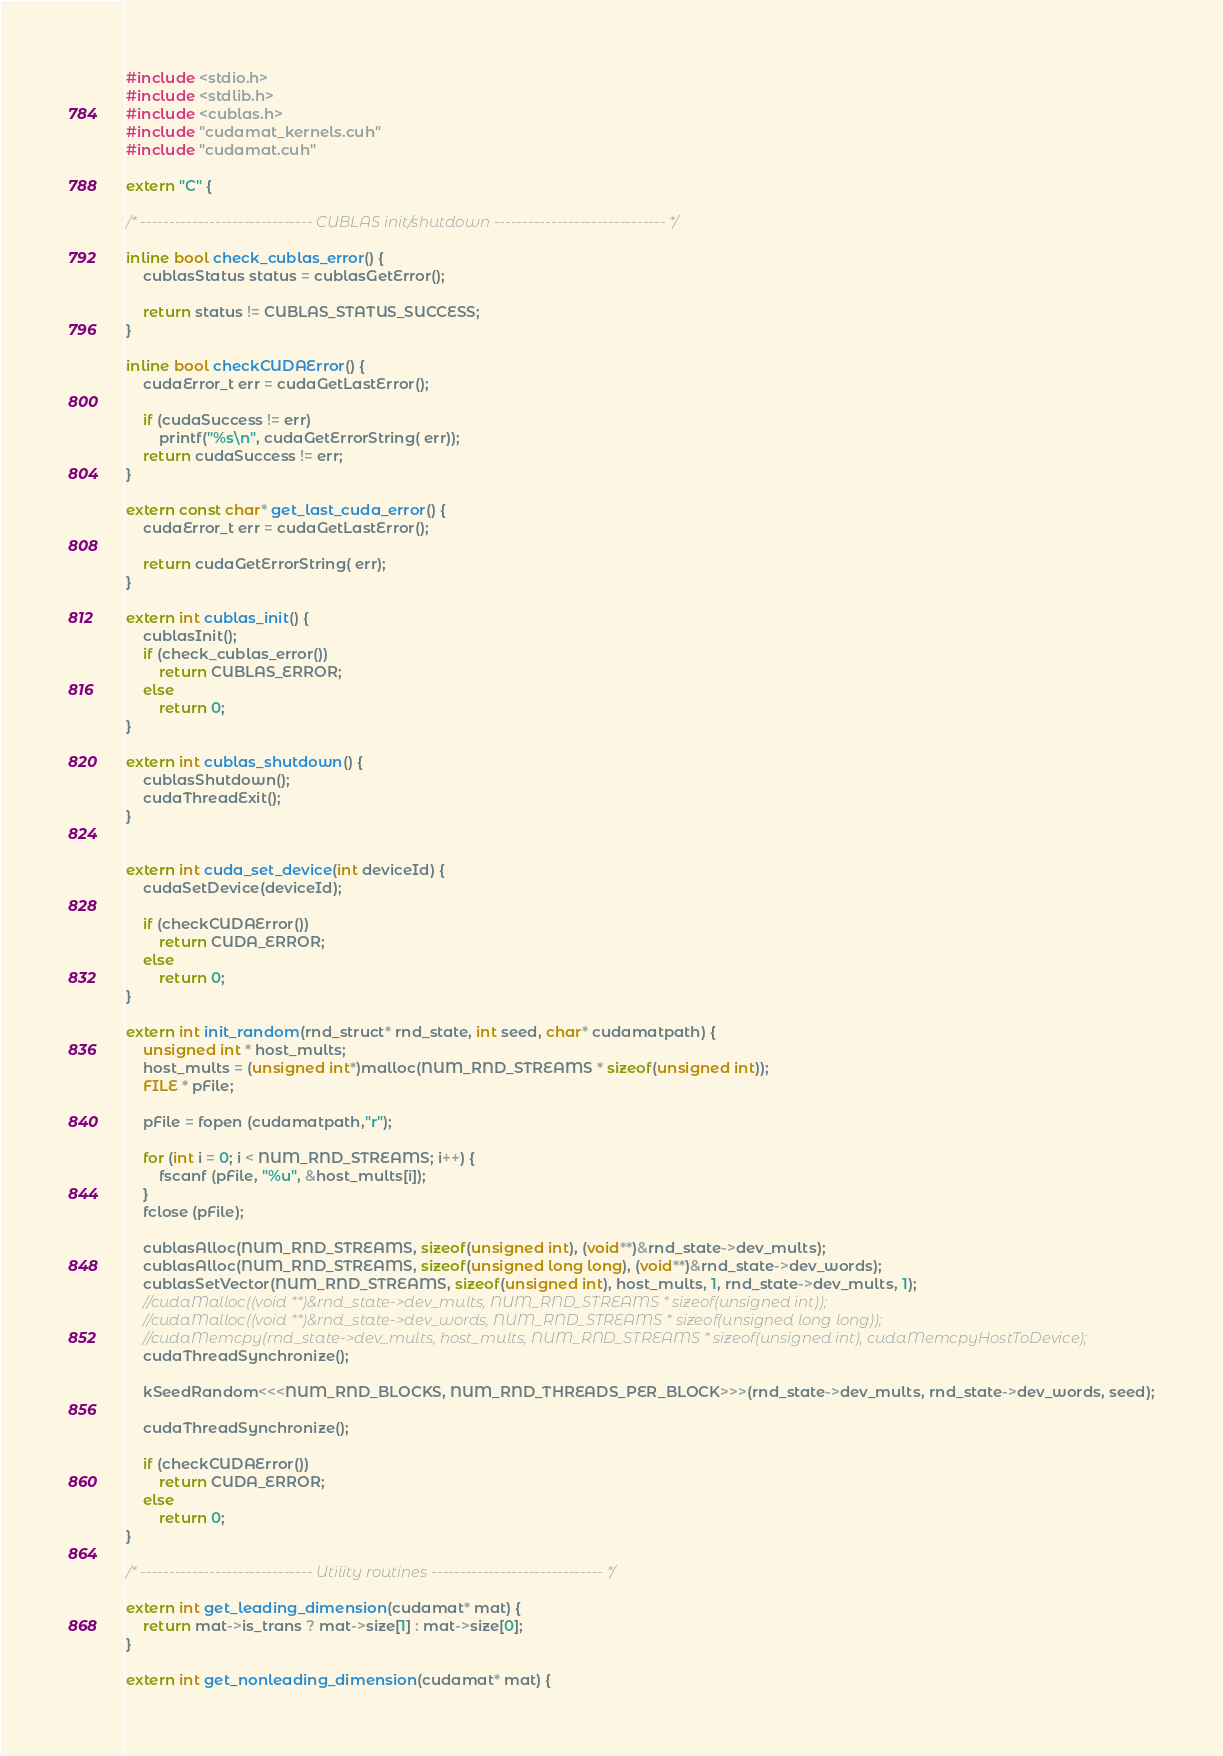Convert code to text. <code><loc_0><loc_0><loc_500><loc_500><_Cuda_>#include <stdio.h>
#include <stdlib.h>
#include <cublas.h>
#include "cudamat_kernels.cuh"
#include "cudamat.cuh"

extern "C" {

/* ------------------------------ CUBLAS init/shutdown ------------------------------ */

inline bool check_cublas_error() {
    cublasStatus status = cublasGetError();

    return status != CUBLAS_STATUS_SUCCESS;
}

inline bool checkCUDAError() {
    cudaError_t err = cudaGetLastError();

    if (cudaSuccess != err)
        printf("%s\n", cudaGetErrorString( err));
    return cudaSuccess != err;
}

extern const char* get_last_cuda_error() {
    cudaError_t err = cudaGetLastError();

    return cudaGetErrorString( err);
}

extern int cublas_init() {
    cublasInit();
    if (check_cublas_error())
        return CUBLAS_ERROR;
    else
        return 0;
}

extern int cublas_shutdown() {
    cublasShutdown();
    cudaThreadExit();
}


extern int cuda_set_device(int deviceId) {
    cudaSetDevice(deviceId);
    
    if (checkCUDAError())
        return CUDA_ERROR;
    else
        return 0;
}

extern int init_random(rnd_struct* rnd_state, int seed, char* cudamatpath) {
    unsigned int * host_mults;
    host_mults = (unsigned int*)malloc(NUM_RND_STREAMS * sizeof(unsigned int));
    FILE * pFile;

    pFile = fopen (cudamatpath,"r");

    for (int i = 0; i < NUM_RND_STREAMS; i++) {
        fscanf (pFile, "%u", &host_mults[i]);
    }
    fclose (pFile);

    cublasAlloc(NUM_RND_STREAMS, sizeof(unsigned int), (void**)&rnd_state->dev_mults);
    cublasAlloc(NUM_RND_STREAMS, sizeof(unsigned long long), (void**)&rnd_state->dev_words);
    cublasSetVector(NUM_RND_STREAMS, sizeof(unsigned int), host_mults, 1, rnd_state->dev_mults, 1);
    //cudaMalloc((void **)&rnd_state->dev_mults, NUM_RND_STREAMS * sizeof(unsigned int));
    //cudaMalloc((void **)&rnd_state->dev_words, NUM_RND_STREAMS * sizeof(unsigned long long));
    //cudaMemcpy(rnd_state->dev_mults, host_mults, NUM_RND_STREAMS * sizeof(unsigned int), cudaMemcpyHostToDevice);
    cudaThreadSynchronize();

    kSeedRandom<<<NUM_RND_BLOCKS, NUM_RND_THREADS_PER_BLOCK>>>(rnd_state->dev_mults, rnd_state->dev_words, seed);

    cudaThreadSynchronize();

    if (checkCUDAError())
        return CUDA_ERROR;
    else
        return 0;
}

/* ------------------------------ Utility routines ------------------------------ */

extern int get_leading_dimension(cudamat* mat) {
    return mat->is_trans ? mat->size[1] : mat->size[0];
}

extern int get_nonleading_dimension(cudamat* mat) {</code> 